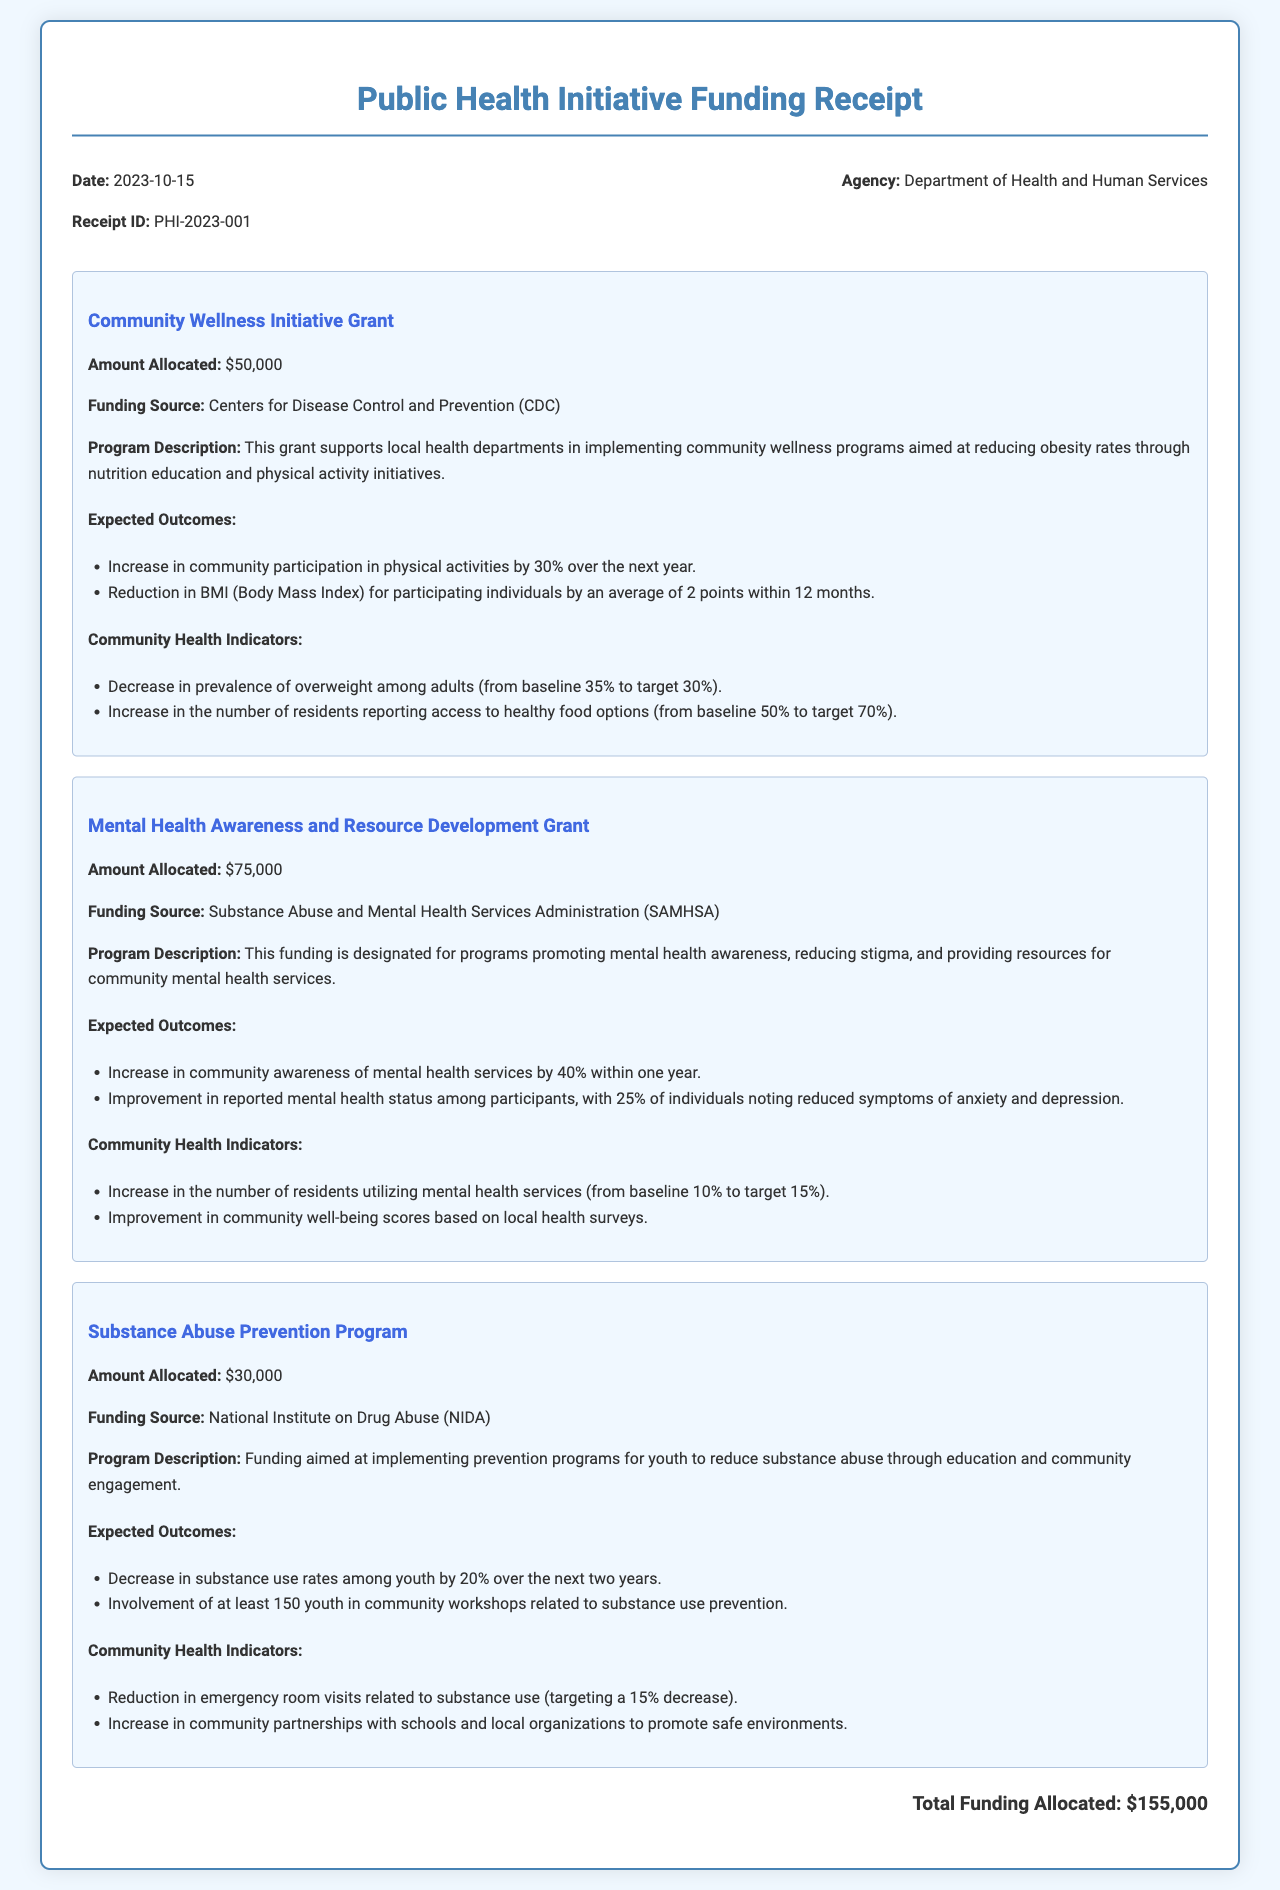What is the date of the receipt? The date is listed in the header section of the document.
Answer: 2023-10-15 What is the total funding allocated? The total funding is calculated based on the individual grant amounts listed.
Answer: $155,000 What is the funding source for the Community Wellness Initiative Grant? The funding source is mentioned directly under the grant description.
Answer: Centers for Disease Control and Prevention (CDC) How much is allocated for the Mental Health Awareness and Resource Development Grant? The amount is specified in the grant section of the document.
Answer: $75,000 What is the expected outcome for community participation in physical activities? The expected outcome is explicitly stated following the grant description.
Answer: Increase in community participation in physical activities by 30% over the next year What health indicator targets a decrease in the prevalence of overweight among adults? This target is outlined in the Community Health Indicators section of the Community Wellness Initiative Grant.
Answer: Decrease in prevalence of overweight among adults (from baseline 35% to target 30%) How many youth are expected to be involved in the Substance Abuse Prevention Program workshops? The expected involvement is described within the grant's expected outcomes.
Answer: At least 150 youth What is the program description for the Substance Abuse Prevention Program? The program description is provided to summarize the intent and focus of the grant.
Answer: Funding aimed at implementing prevention programs for youth to reduce substance abuse through education and community engagement 